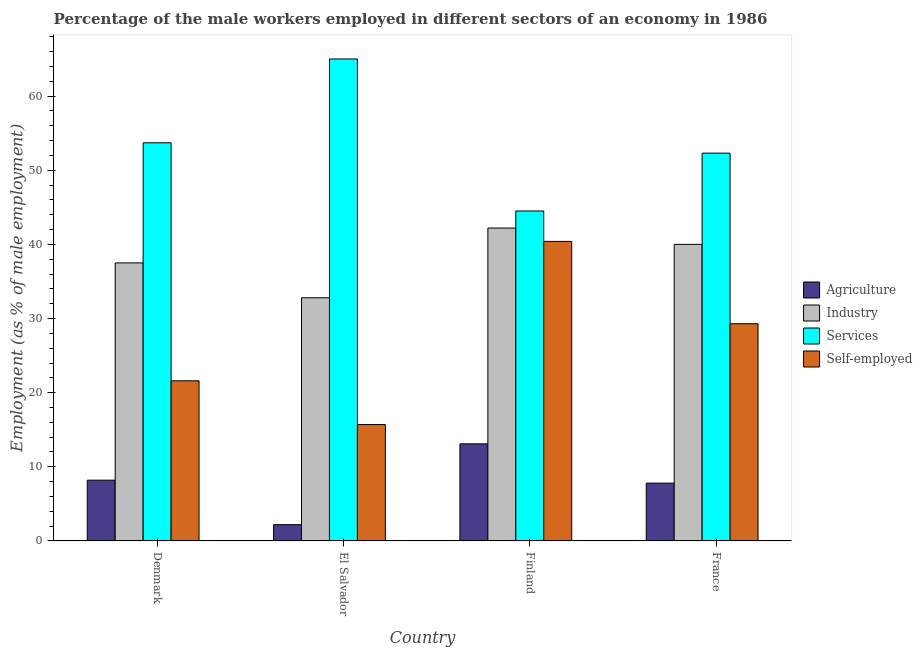How many groups of bars are there?
Your response must be concise. 4. Are the number of bars per tick equal to the number of legend labels?
Keep it short and to the point. Yes. Are the number of bars on each tick of the X-axis equal?
Make the answer very short. Yes. What is the label of the 4th group of bars from the left?
Your response must be concise. France. What is the percentage of male workers in industry in El Salvador?
Give a very brief answer. 32.8. Across all countries, what is the maximum percentage of self employed male workers?
Your answer should be very brief. 40.4. Across all countries, what is the minimum percentage of self employed male workers?
Provide a succinct answer. 15.7. In which country was the percentage of male workers in industry minimum?
Make the answer very short. El Salvador. What is the total percentage of male workers in industry in the graph?
Your answer should be very brief. 152.5. What is the difference between the percentage of male workers in industry in El Salvador and that in Finland?
Provide a short and direct response. -9.4. What is the difference between the percentage of male workers in services in El Salvador and the percentage of male workers in industry in Finland?
Your response must be concise. 22.8. What is the average percentage of male workers in services per country?
Ensure brevity in your answer.  53.88. What is the difference between the percentage of male workers in services and percentage of self employed male workers in Denmark?
Ensure brevity in your answer.  32.1. What is the ratio of the percentage of male workers in services in Finland to that in France?
Offer a terse response. 0.85. Is the percentage of male workers in industry in El Salvador less than that in France?
Offer a very short reply. Yes. Is the difference between the percentage of male workers in services in El Salvador and France greater than the difference between the percentage of male workers in industry in El Salvador and France?
Your answer should be compact. Yes. What is the difference between the highest and the second highest percentage of self employed male workers?
Keep it short and to the point. 11.1. What is the difference between the highest and the lowest percentage of male workers in services?
Your response must be concise. 20.5. In how many countries, is the percentage of self employed male workers greater than the average percentage of self employed male workers taken over all countries?
Keep it short and to the point. 2. Is the sum of the percentage of self employed male workers in El Salvador and Finland greater than the maximum percentage of male workers in agriculture across all countries?
Provide a short and direct response. Yes. What does the 3rd bar from the left in Denmark represents?
Keep it short and to the point. Services. What does the 4th bar from the right in Finland represents?
Your answer should be very brief. Agriculture. How many bars are there?
Give a very brief answer. 16. Does the graph contain any zero values?
Provide a short and direct response. No. Does the graph contain grids?
Keep it short and to the point. No. Where does the legend appear in the graph?
Give a very brief answer. Center right. How are the legend labels stacked?
Offer a terse response. Vertical. What is the title of the graph?
Offer a terse response. Percentage of the male workers employed in different sectors of an economy in 1986. What is the label or title of the X-axis?
Offer a very short reply. Country. What is the label or title of the Y-axis?
Provide a succinct answer. Employment (as % of male employment). What is the Employment (as % of male employment) of Agriculture in Denmark?
Your answer should be compact. 8.2. What is the Employment (as % of male employment) in Industry in Denmark?
Your answer should be compact. 37.5. What is the Employment (as % of male employment) of Services in Denmark?
Your response must be concise. 53.7. What is the Employment (as % of male employment) of Self-employed in Denmark?
Ensure brevity in your answer.  21.6. What is the Employment (as % of male employment) in Agriculture in El Salvador?
Provide a succinct answer. 2.2. What is the Employment (as % of male employment) of Industry in El Salvador?
Make the answer very short. 32.8. What is the Employment (as % of male employment) of Self-employed in El Salvador?
Provide a succinct answer. 15.7. What is the Employment (as % of male employment) in Agriculture in Finland?
Your answer should be compact. 13.1. What is the Employment (as % of male employment) in Industry in Finland?
Provide a succinct answer. 42.2. What is the Employment (as % of male employment) in Services in Finland?
Provide a short and direct response. 44.5. What is the Employment (as % of male employment) in Self-employed in Finland?
Your response must be concise. 40.4. What is the Employment (as % of male employment) in Agriculture in France?
Offer a terse response. 7.8. What is the Employment (as % of male employment) in Services in France?
Provide a short and direct response. 52.3. What is the Employment (as % of male employment) in Self-employed in France?
Provide a short and direct response. 29.3. Across all countries, what is the maximum Employment (as % of male employment) in Agriculture?
Your response must be concise. 13.1. Across all countries, what is the maximum Employment (as % of male employment) of Industry?
Give a very brief answer. 42.2. Across all countries, what is the maximum Employment (as % of male employment) in Services?
Your answer should be very brief. 65. Across all countries, what is the maximum Employment (as % of male employment) of Self-employed?
Your answer should be compact. 40.4. Across all countries, what is the minimum Employment (as % of male employment) in Agriculture?
Offer a very short reply. 2.2. Across all countries, what is the minimum Employment (as % of male employment) of Industry?
Your response must be concise. 32.8. Across all countries, what is the minimum Employment (as % of male employment) in Services?
Provide a succinct answer. 44.5. Across all countries, what is the minimum Employment (as % of male employment) of Self-employed?
Provide a succinct answer. 15.7. What is the total Employment (as % of male employment) in Agriculture in the graph?
Your answer should be compact. 31.3. What is the total Employment (as % of male employment) in Industry in the graph?
Your answer should be very brief. 152.5. What is the total Employment (as % of male employment) in Services in the graph?
Give a very brief answer. 215.5. What is the total Employment (as % of male employment) in Self-employed in the graph?
Give a very brief answer. 107. What is the difference between the Employment (as % of male employment) in Services in Denmark and that in El Salvador?
Your response must be concise. -11.3. What is the difference between the Employment (as % of male employment) in Agriculture in Denmark and that in Finland?
Give a very brief answer. -4.9. What is the difference between the Employment (as % of male employment) of Services in Denmark and that in Finland?
Provide a short and direct response. 9.2. What is the difference between the Employment (as % of male employment) of Self-employed in Denmark and that in Finland?
Your response must be concise. -18.8. What is the difference between the Employment (as % of male employment) of Agriculture in Denmark and that in France?
Offer a terse response. 0.4. What is the difference between the Employment (as % of male employment) in Industry in Denmark and that in France?
Your response must be concise. -2.5. What is the difference between the Employment (as % of male employment) in Services in Denmark and that in France?
Offer a terse response. 1.4. What is the difference between the Employment (as % of male employment) in Industry in El Salvador and that in Finland?
Offer a terse response. -9.4. What is the difference between the Employment (as % of male employment) of Services in El Salvador and that in Finland?
Offer a very short reply. 20.5. What is the difference between the Employment (as % of male employment) in Self-employed in El Salvador and that in Finland?
Make the answer very short. -24.7. What is the difference between the Employment (as % of male employment) of Agriculture in El Salvador and that in France?
Offer a very short reply. -5.6. What is the difference between the Employment (as % of male employment) of Services in El Salvador and that in France?
Provide a short and direct response. 12.7. What is the difference between the Employment (as % of male employment) of Self-employed in El Salvador and that in France?
Make the answer very short. -13.6. What is the difference between the Employment (as % of male employment) of Industry in Finland and that in France?
Offer a terse response. 2.2. What is the difference between the Employment (as % of male employment) in Services in Finland and that in France?
Offer a terse response. -7.8. What is the difference between the Employment (as % of male employment) of Agriculture in Denmark and the Employment (as % of male employment) of Industry in El Salvador?
Provide a short and direct response. -24.6. What is the difference between the Employment (as % of male employment) of Agriculture in Denmark and the Employment (as % of male employment) of Services in El Salvador?
Offer a very short reply. -56.8. What is the difference between the Employment (as % of male employment) in Agriculture in Denmark and the Employment (as % of male employment) in Self-employed in El Salvador?
Offer a terse response. -7.5. What is the difference between the Employment (as % of male employment) of Industry in Denmark and the Employment (as % of male employment) of Services in El Salvador?
Make the answer very short. -27.5. What is the difference between the Employment (as % of male employment) of Industry in Denmark and the Employment (as % of male employment) of Self-employed in El Salvador?
Your answer should be compact. 21.8. What is the difference between the Employment (as % of male employment) of Services in Denmark and the Employment (as % of male employment) of Self-employed in El Salvador?
Your response must be concise. 38. What is the difference between the Employment (as % of male employment) in Agriculture in Denmark and the Employment (as % of male employment) in Industry in Finland?
Provide a short and direct response. -34. What is the difference between the Employment (as % of male employment) in Agriculture in Denmark and the Employment (as % of male employment) in Services in Finland?
Keep it short and to the point. -36.3. What is the difference between the Employment (as % of male employment) in Agriculture in Denmark and the Employment (as % of male employment) in Self-employed in Finland?
Ensure brevity in your answer.  -32.2. What is the difference between the Employment (as % of male employment) in Agriculture in Denmark and the Employment (as % of male employment) in Industry in France?
Your answer should be very brief. -31.8. What is the difference between the Employment (as % of male employment) of Agriculture in Denmark and the Employment (as % of male employment) of Services in France?
Make the answer very short. -44.1. What is the difference between the Employment (as % of male employment) in Agriculture in Denmark and the Employment (as % of male employment) in Self-employed in France?
Offer a terse response. -21.1. What is the difference between the Employment (as % of male employment) in Industry in Denmark and the Employment (as % of male employment) in Services in France?
Offer a terse response. -14.8. What is the difference between the Employment (as % of male employment) of Services in Denmark and the Employment (as % of male employment) of Self-employed in France?
Your answer should be very brief. 24.4. What is the difference between the Employment (as % of male employment) of Agriculture in El Salvador and the Employment (as % of male employment) of Services in Finland?
Make the answer very short. -42.3. What is the difference between the Employment (as % of male employment) of Agriculture in El Salvador and the Employment (as % of male employment) of Self-employed in Finland?
Keep it short and to the point. -38.2. What is the difference between the Employment (as % of male employment) in Services in El Salvador and the Employment (as % of male employment) in Self-employed in Finland?
Provide a succinct answer. 24.6. What is the difference between the Employment (as % of male employment) of Agriculture in El Salvador and the Employment (as % of male employment) of Industry in France?
Offer a terse response. -37.8. What is the difference between the Employment (as % of male employment) of Agriculture in El Salvador and the Employment (as % of male employment) of Services in France?
Make the answer very short. -50.1. What is the difference between the Employment (as % of male employment) of Agriculture in El Salvador and the Employment (as % of male employment) of Self-employed in France?
Offer a terse response. -27.1. What is the difference between the Employment (as % of male employment) in Industry in El Salvador and the Employment (as % of male employment) in Services in France?
Offer a very short reply. -19.5. What is the difference between the Employment (as % of male employment) of Services in El Salvador and the Employment (as % of male employment) of Self-employed in France?
Give a very brief answer. 35.7. What is the difference between the Employment (as % of male employment) in Agriculture in Finland and the Employment (as % of male employment) in Industry in France?
Offer a very short reply. -26.9. What is the difference between the Employment (as % of male employment) of Agriculture in Finland and the Employment (as % of male employment) of Services in France?
Your answer should be very brief. -39.2. What is the difference between the Employment (as % of male employment) of Agriculture in Finland and the Employment (as % of male employment) of Self-employed in France?
Give a very brief answer. -16.2. What is the difference between the Employment (as % of male employment) of Industry in Finland and the Employment (as % of male employment) of Services in France?
Make the answer very short. -10.1. What is the average Employment (as % of male employment) in Agriculture per country?
Ensure brevity in your answer.  7.83. What is the average Employment (as % of male employment) in Industry per country?
Ensure brevity in your answer.  38.12. What is the average Employment (as % of male employment) of Services per country?
Your answer should be very brief. 53.88. What is the average Employment (as % of male employment) of Self-employed per country?
Make the answer very short. 26.75. What is the difference between the Employment (as % of male employment) of Agriculture and Employment (as % of male employment) of Industry in Denmark?
Provide a short and direct response. -29.3. What is the difference between the Employment (as % of male employment) in Agriculture and Employment (as % of male employment) in Services in Denmark?
Your answer should be very brief. -45.5. What is the difference between the Employment (as % of male employment) of Agriculture and Employment (as % of male employment) of Self-employed in Denmark?
Keep it short and to the point. -13.4. What is the difference between the Employment (as % of male employment) in Industry and Employment (as % of male employment) in Services in Denmark?
Your answer should be very brief. -16.2. What is the difference between the Employment (as % of male employment) in Services and Employment (as % of male employment) in Self-employed in Denmark?
Your response must be concise. 32.1. What is the difference between the Employment (as % of male employment) in Agriculture and Employment (as % of male employment) in Industry in El Salvador?
Ensure brevity in your answer.  -30.6. What is the difference between the Employment (as % of male employment) in Agriculture and Employment (as % of male employment) in Services in El Salvador?
Offer a very short reply. -62.8. What is the difference between the Employment (as % of male employment) of Agriculture and Employment (as % of male employment) of Self-employed in El Salvador?
Your response must be concise. -13.5. What is the difference between the Employment (as % of male employment) in Industry and Employment (as % of male employment) in Services in El Salvador?
Ensure brevity in your answer.  -32.2. What is the difference between the Employment (as % of male employment) in Industry and Employment (as % of male employment) in Self-employed in El Salvador?
Your response must be concise. 17.1. What is the difference between the Employment (as % of male employment) in Services and Employment (as % of male employment) in Self-employed in El Salvador?
Keep it short and to the point. 49.3. What is the difference between the Employment (as % of male employment) in Agriculture and Employment (as % of male employment) in Industry in Finland?
Give a very brief answer. -29.1. What is the difference between the Employment (as % of male employment) of Agriculture and Employment (as % of male employment) of Services in Finland?
Offer a terse response. -31.4. What is the difference between the Employment (as % of male employment) of Agriculture and Employment (as % of male employment) of Self-employed in Finland?
Offer a terse response. -27.3. What is the difference between the Employment (as % of male employment) of Industry and Employment (as % of male employment) of Self-employed in Finland?
Keep it short and to the point. 1.8. What is the difference between the Employment (as % of male employment) of Agriculture and Employment (as % of male employment) of Industry in France?
Your response must be concise. -32.2. What is the difference between the Employment (as % of male employment) in Agriculture and Employment (as % of male employment) in Services in France?
Offer a very short reply. -44.5. What is the difference between the Employment (as % of male employment) in Agriculture and Employment (as % of male employment) in Self-employed in France?
Offer a very short reply. -21.5. What is the difference between the Employment (as % of male employment) of Industry and Employment (as % of male employment) of Self-employed in France?
Offer a terse response. 10.7. What is the ratio of the Employment (as % of male employment) in Agriculture in Denmark to that in El Salvador?
Your response must be concise. 3.73. What is the ratio of the Employment (as % of male employment) in Industry in Denmark to that in El Salvador?
Offer a very short reply. 1.14. What is the ratio of the Employment (as % of male employment) of Services in Denmark to that in El Salvador?
Your answer should be compact. 0.83. What is the ratio of the Employment (as % of male employment) in Self-employed in Denmark to that in El Salvador?
Provide a short and direct response. 1.38. What is the ratio of the Employment (as % of male employment) of Agriculture in Denmark to that in Finland?
Make the answer very short. 0.63. What is the ratio of the Employment (as % of male employment) in Industry in Denmark to that in Finland?
Offer a very short reply. 0.89. What is the ratio of the Employment (as % of male employment) in Services in Denmark to that in Finland?
Ensure brevity in your answer.  1.21. What is the ratio of the Employment (as % of male employment) in Self-employed in Denmark to that in Finland?
Keep it short and to the point. 0.53. What is the ratio of the Employment (as % of male employment) in Agriculture in Denmark to that in France?
Offer a very short reply. 1.05. What is the ratio of the Employment (as % of male employment) of Services in Denmark to that in France?
Offer a terse response. 1.03. What is the ratio of the Employment (as % of male employment) of Self-employed in Denmark to that in France?
Provide a short and direct response. 0.74. What is the ratio of the Employment (as % of male employment) in Agriculture in El Salvador to that in Finland?
Offer a very short reply. 0.17. What is the ratio of the Employment (as % of male employment) of Industry in El Salvador to that in Finland?
Ensure brevity in your answer.  0.78. What is the ratio of the Employment (as % of male employment) in Services in El Salvador to that in Finland?
Provide a succinct answer. 1.46. What is the ratio of the Employment (as % of male employment) in Self-employed in El Salvador to that in Finland?
Keep it short and to the point. 0.39. What is the ratio of the Employment (as % of male employment) of Agriculture in El Salvador to that in France?
Make the answer very short. 0.28. What is the ratio of the Employment (as % of male employment) of Industry in El Salvador to that in France?
Your answer should be very brief. 0.82. What is the ratio of the Employment (as % of male employment) in Services in El Salvador to that in France?
Provide a short and direct response. 1.24. What is the ratio of the Employment (as % of male employment) of Self-employed in El Salvador to that in France?
Keep it short and to the point. 0.54. What is the ratio of the Employment (as % of male employment) of Agriculture in Finland to that in France?
Give a very brief answer. 1.68. What is the ratio of the Employment (as % of male employment) in Industry in Finland to that in France?
Offer a terse response. 1.05. What is the ratio of the Employment (as % of male employment) of Services in Finland to that in France?
Your answer should be compact. 0.85. What is the ratio of the Employment (as % of male employment) in Self-employed in Finland to that in France?
Provide a short and direct response. 1.38. What is the difference between the highest and the second highest Employment (as % of male employment) of Agriculture?
Keep it short and to the point. 4.9. What is the difference between the highest and the second highest Employment (as % of male employment) of Industry?
Offer a very short reply. 2.2. What is the difference between the highest and the lowest Employment (as % of male employment) in Services?
Your answer should be compact. 20.5. What is the difference between the highest and the lowest Employment (as % of male employment) of Self-employed?
Your response must be concise. 24.7. 